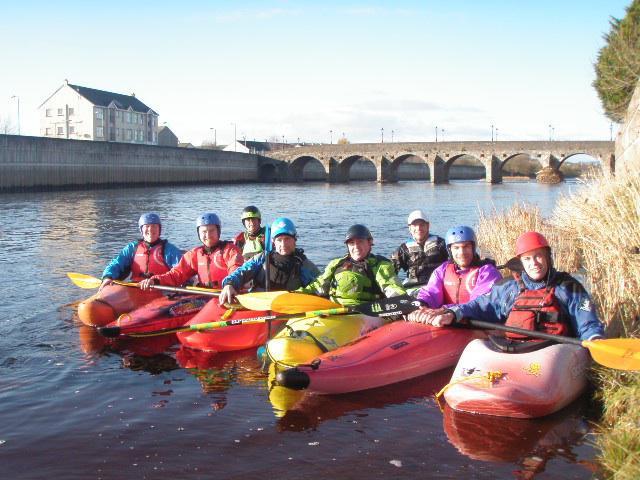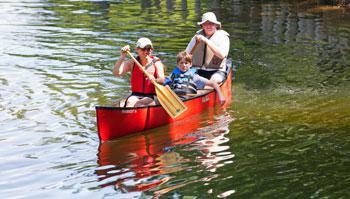The first image is the image on the left, the second image is the image on the right. Analyze the images presented: Is the assertion "In at least one of the images, people are shown outside of the canoe." valid? Answer yes or no. No. The first image is the image on the left, the second image is the image on the right. For the images shown, is this caption "One image shows people standing along one side of a canoe instead of sitting in it." true? Answer yes or no. No. 